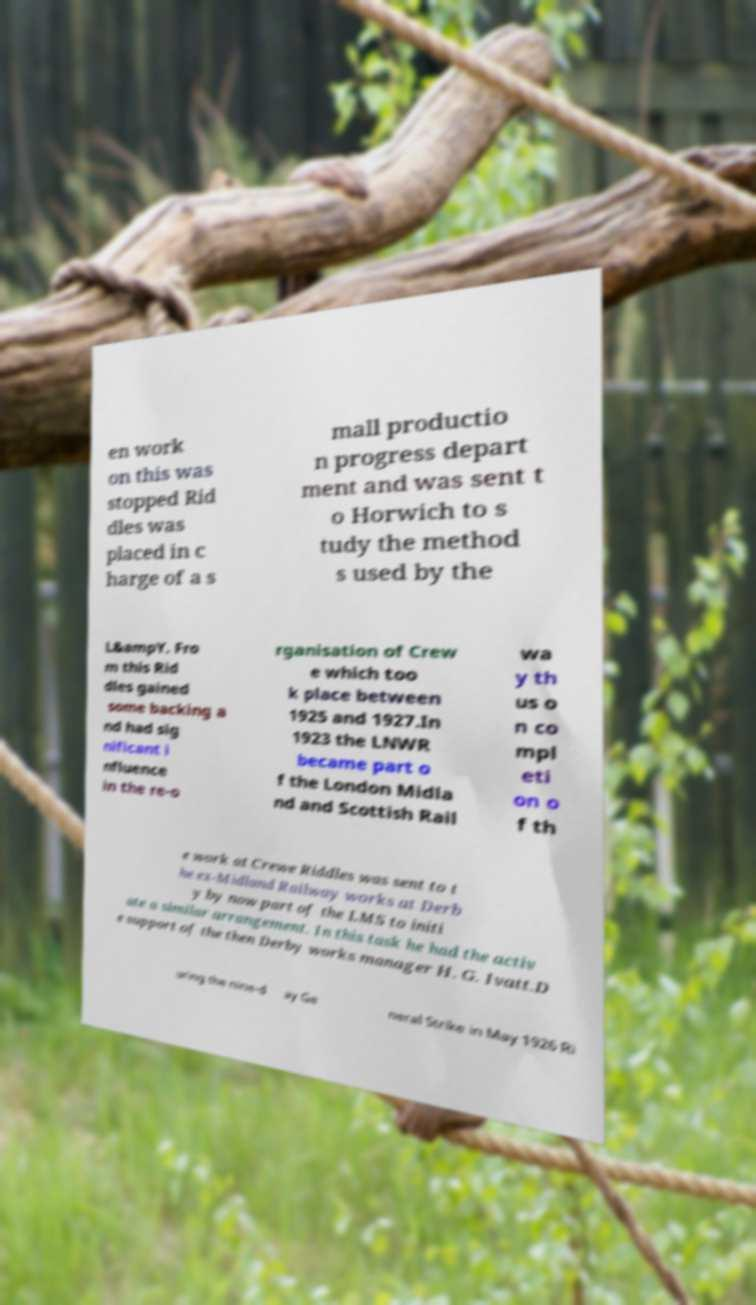Please identify and transcribe the text found in this image. en work on this was stopped Rid dles was placed in c harge of a s mall productio n progress depart ment and was sent t o Horwich to s tudy the method s used by the L&ampY. Fro m this Rid dles gained some backing a nd had sig nificant i nfluence in the re-o rganisation of Crew e which too k place between 1925 and 1927.In 1923 the LNWR became part o f the London Midla nd and Scottish Rail wa y th us o n co mpl eti on o f th e work at Crewe Riddles was sent to t he ex-Midland Railway works at Derb y by now part of the LMS to initi ate a similar arrangement. In this task he had the activ e support of the then Derby works manager H. G. Ivatt.D uring the nine-d ay Ge neral Strike in May 1926 Ri 